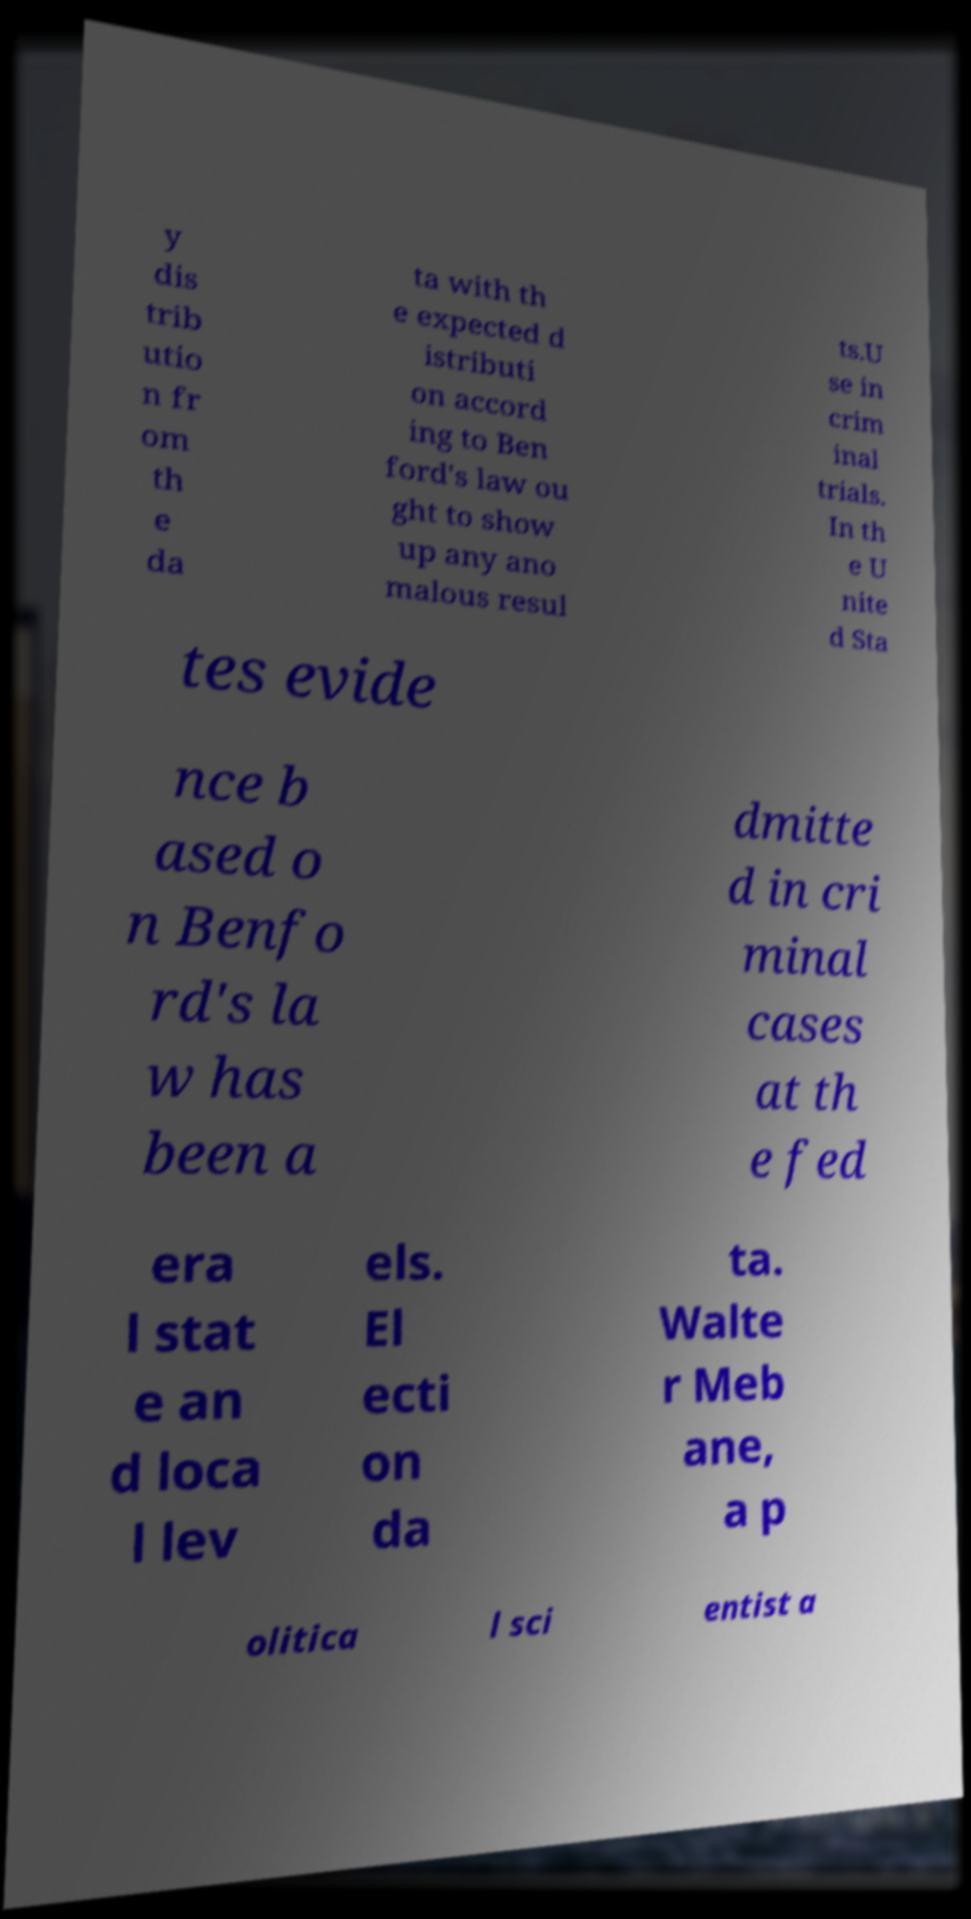Can you accurately transcribe the text from the provided image for me? y dis trib utio n fr om th e da ta with th e expected d istributi on accord ing to Ben ford's law ou ght to show up any ano malous resul ts.U se in crim inal trials. In th e U nite d Sta tes evide nce b ased o n Benfo rd's la w has been a dmitte d in cri minal cases at th e fed era l stat e an d loca l lev els. El ecti on da ta. Walte r Meb ane, a p olitica l sci entist a 